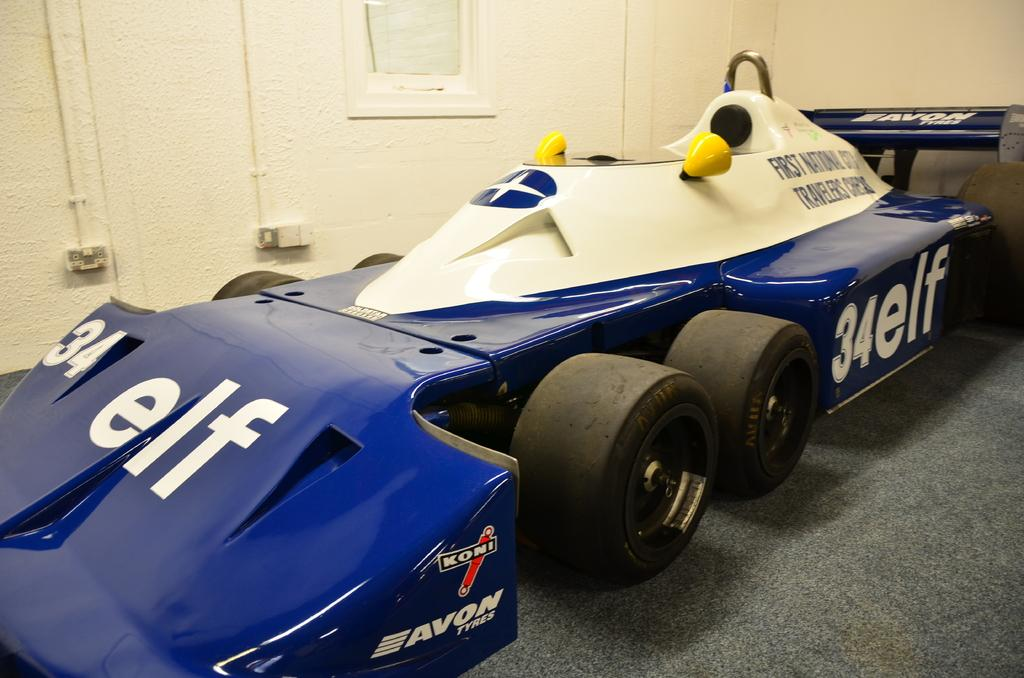What type of vehicle is in the image? There is a sports car in the image. Where is the sports car located? The sports car is on a path. What is behind the sports car? There is a wall behind the sports car. What can be seen on the wall? The wall has pipes on it, and there is an object on the wall. What time is displayed on the clock in the image? There is no clock present in the image. What type of exchange is taking place between the two people in the image? There are no people present in the image, only a sports car, a path, a wall, pipes, and an object on the wall. 